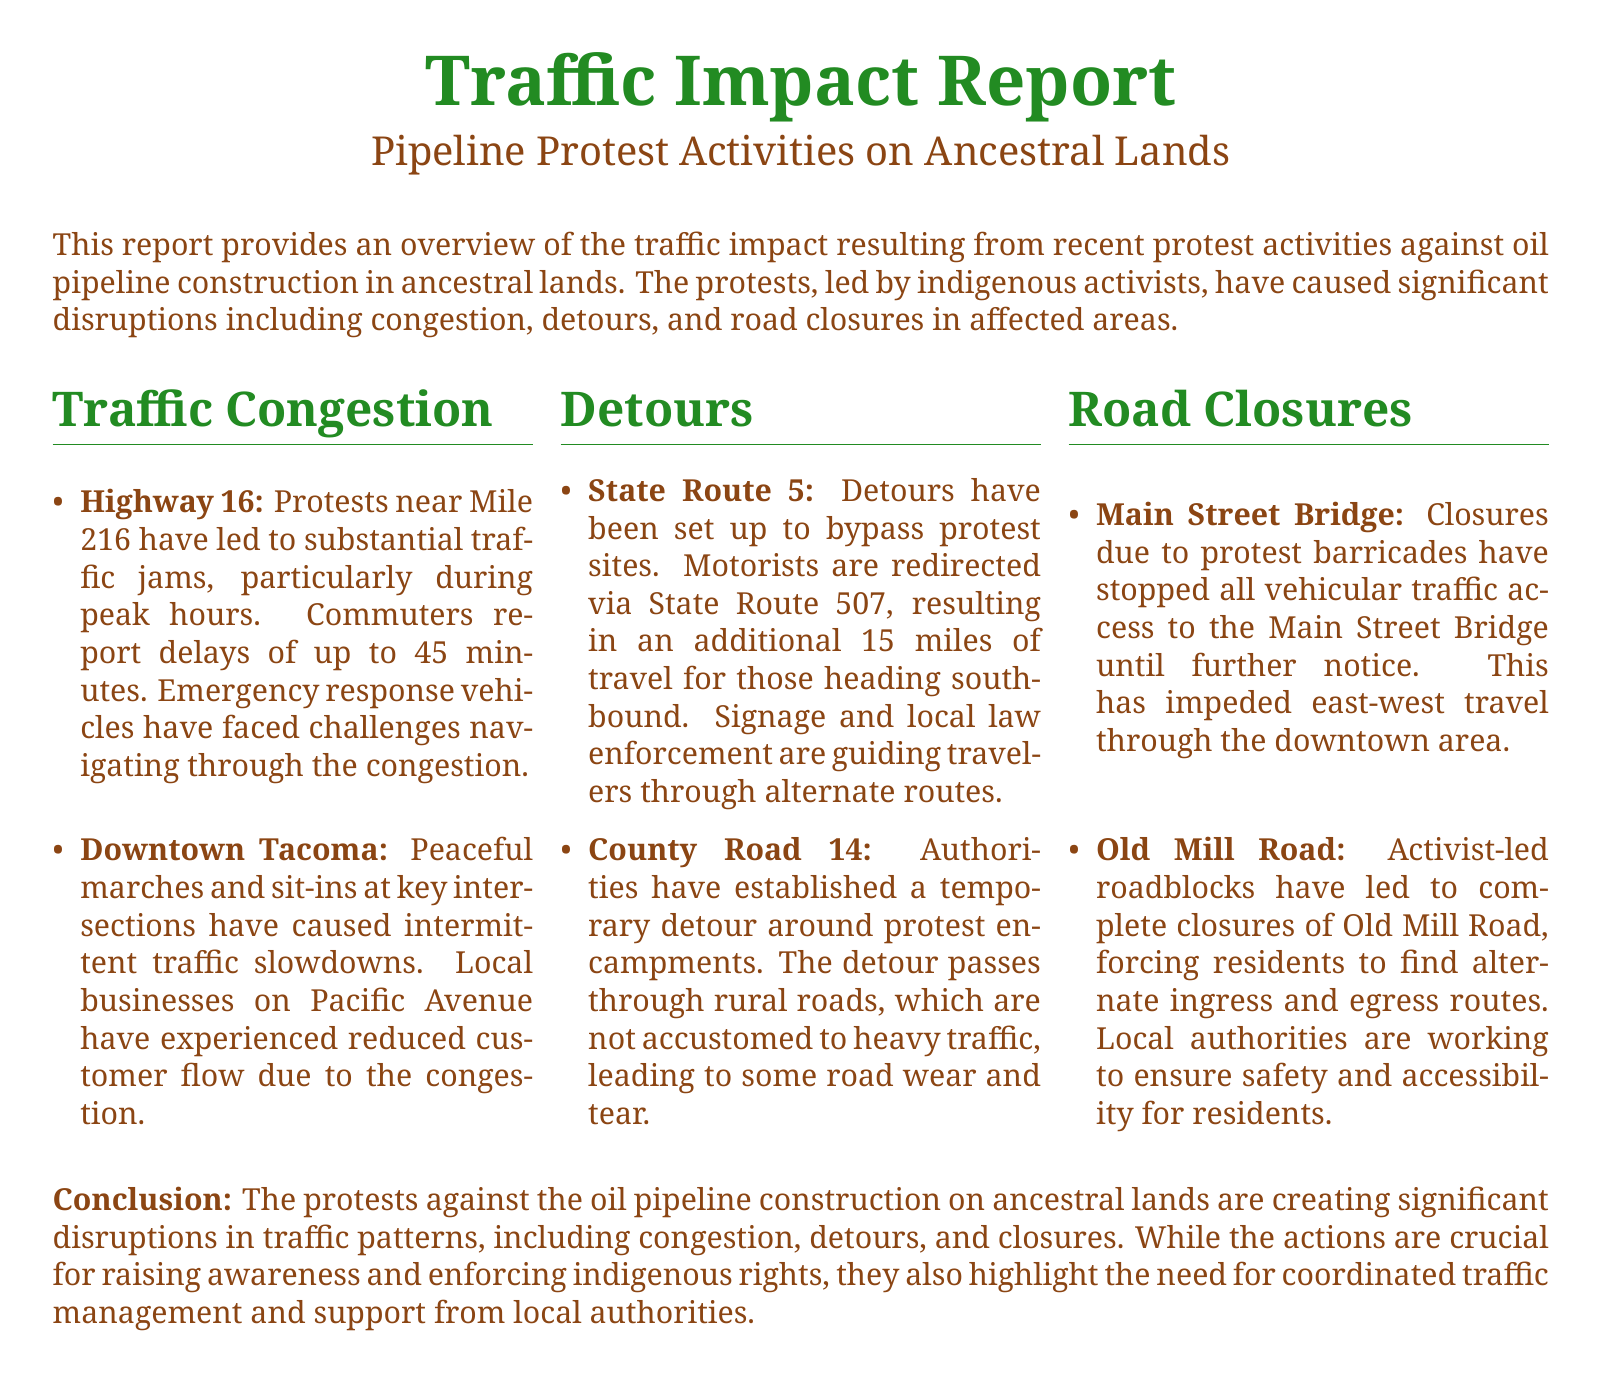what is the location of significant traffic jams? Traffic jams are reported near Mile 216 on Highway 16 due to protests.
Answer: Mile 216 on Highway 16 how long are the delays reported by commuters? Commuters report delays of up to 45 minutes during the traffic jams.
Answer: 45 minutes what alternative route is provided for southbound motorists? Motorists are redirected via State Route 507 to bypass protest sites.
Answer: State Route 507 which road has been closed due to protest barricades? The Main Street Bridge has been closed, stopping all vehicular traffic access.
Answer: Main Street Bridge what is the impact on local businesses in Downtown Tacoma? Local businesses on Pacific Avenue have experienced reduced customer flow due to the congestion.
Answer: Reduced customer flow what additional distance do southbound motorists have to travel due to detours? The detours result in an additional travel distance of 15 miles for southbound motorists.
Answer: 15 miles which road has been completely closed by activist-led roadblocks? Old Mill Road has been completely closed, forcing residents to find alternate routes.
Answer: Old Mill Road how are authorities managing the temporary detours? Authorities are using signage and local law enforcement to guide travelers through alternate routes.
Answer: Signage and local law enforcement 